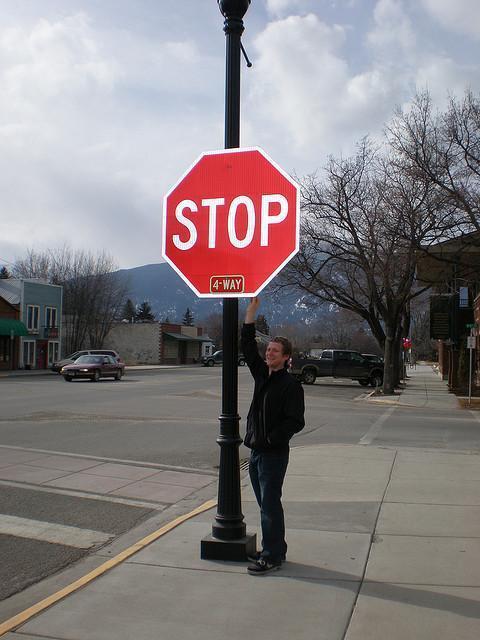How many cars are there?
Give a very brief answer. 1. 